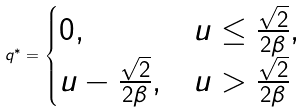<formula> <loc_0><loc_0><loc_500><loc_500>q ^ { * } = \begin{cases} 0 , & u \leq \frac { \sqrt { 2 } } { 2 \beta } , \\ u - \frac { \sqrt { 2 } } { 2 \beta } , & u > \frac { \sqrt { 2 } } { 2 \beta } \end{cases}</formula> 